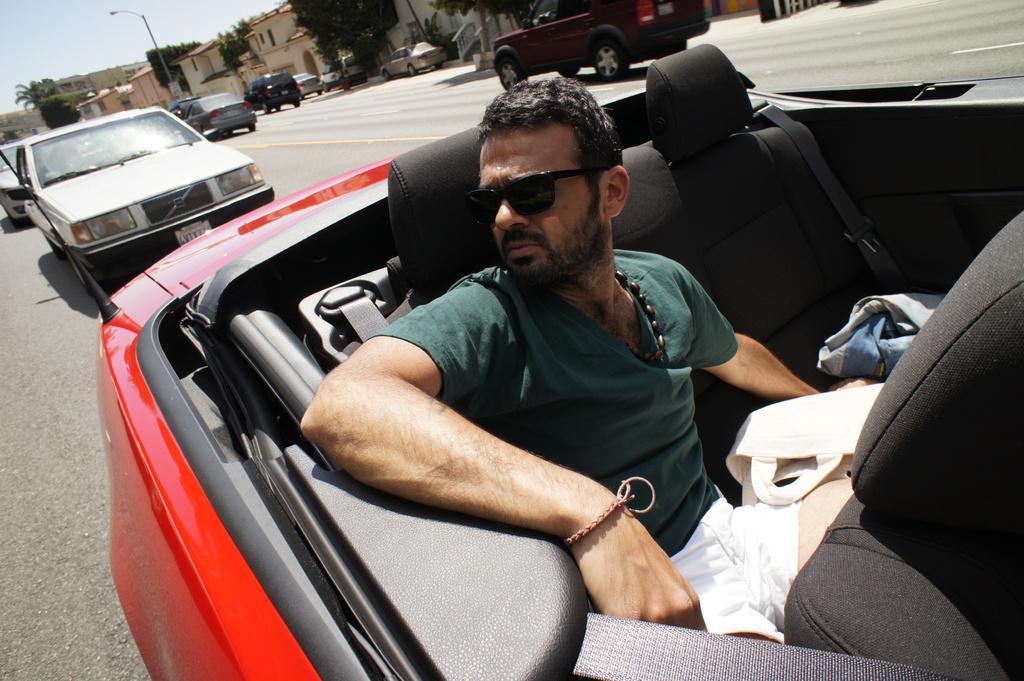Describe this image in one or two sentences. In this image i can see a man sitting in a car on the road at the back ground i can see tree few other cars, pole and sky. 